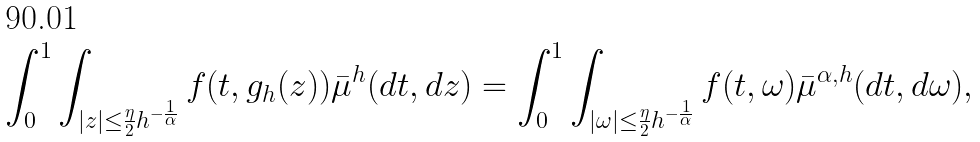<formula> <loc_0><loc_0><loc_500><loc_500>\int _ { 0 } ^ { 1 } \int _ { | z | \leq \frac { \eta } { 2 } h ^ { - \frac { 1 } { \alpha } } } f ( t , g _ { h } ( z ) ) \bar { \mu } ^ { h } ( d t , d z ) = \int _ { 0 } ^ { 1 } \int _ { | \omega | \leq \frac { \eta } { 2 } h ^ { - \frac { 1 } { \alpha } } } f ( t , \omega ) \bar { \mu } ^ { \alpha , h } ( d t , d \omega ) ,</formula> 